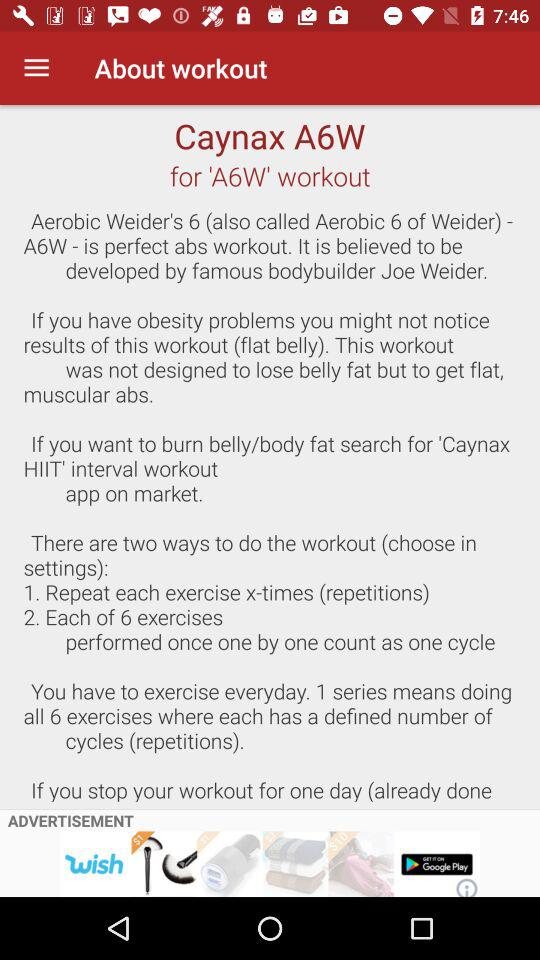How many ways are there to do the workout?
Answer the question using a single word or phrase. 2 